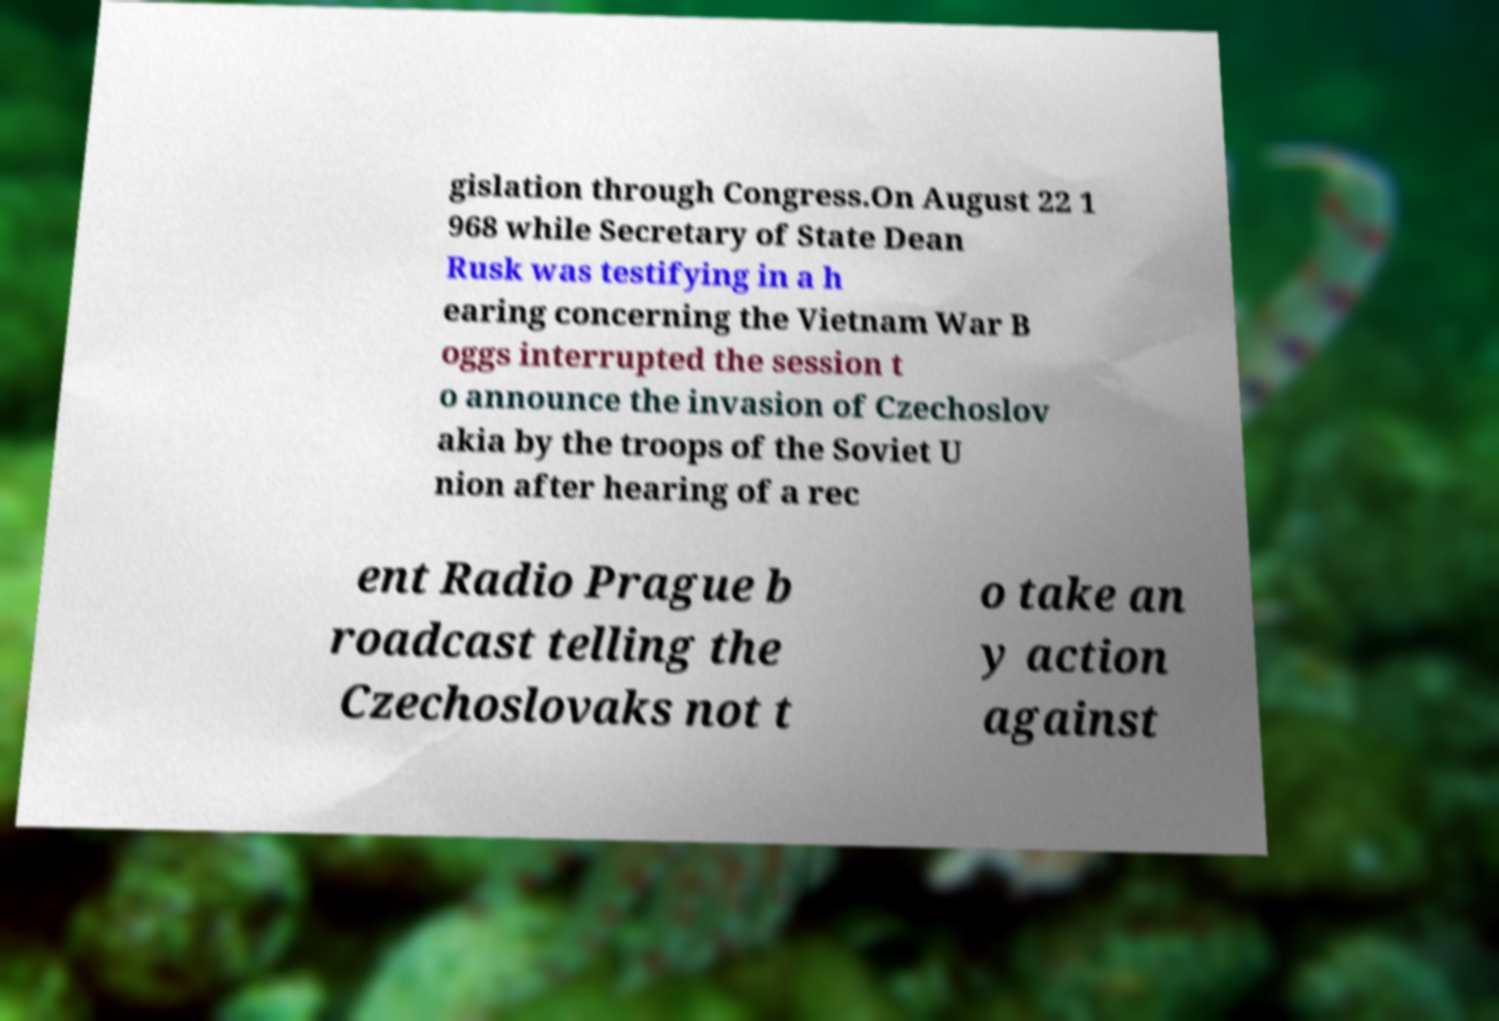Can you accurately transcribe the text from the provided image for me? gislation through Congress.On August 22 1 968 while Secretary of State Dean Rusk was testifying in a h earing concerning the Vietnam War B oggs interrupted the session t o announce the invasion of Czechoslov akia by the troops of the Soviet U nion after hearing of a rec ent Radio Prague b roadcast telling the Czechoslovaks not t o take an y action against 